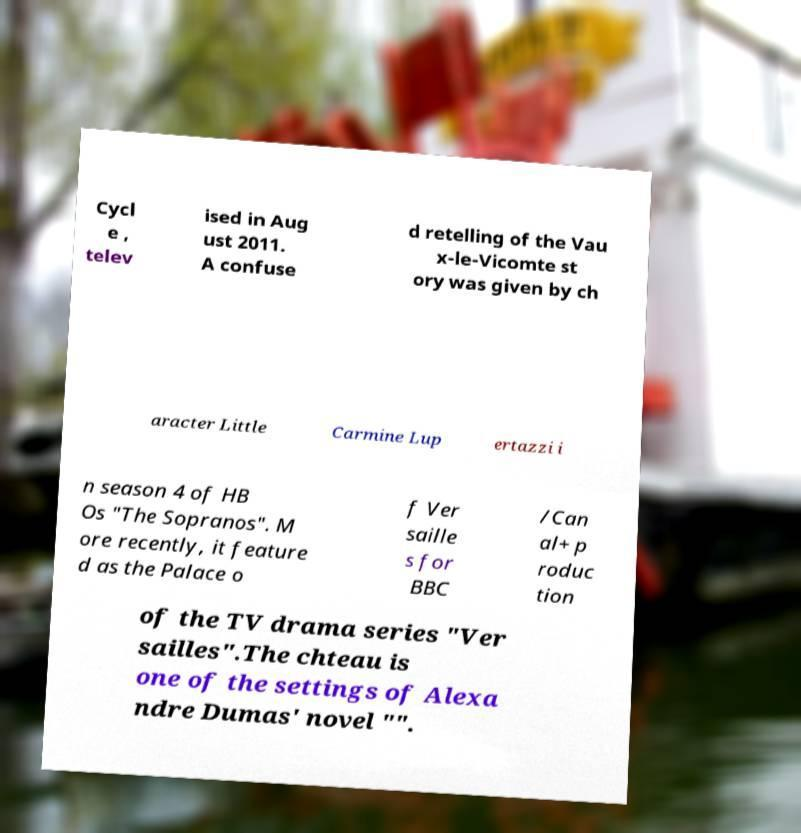Can you read and provide the text displayed in the image?This photo seems to have some interesting text. Can you extract and type it out for me? Cycl e , telev ised in Aug ust 2011. A confuse d retelling of the Vau x-le-Vicomte st ory was given by ch aracter Little Carmine Lup ertazzi i n season 4 of HB Os "The Sopranos". M ore recently, it feature d as the Palace o f Ver saille s for BBC /Can al+ p roduc tion of the TV drama series "Ver sailles".The chteau is one of the settings of Alexa ndre Dumas' novel "". 